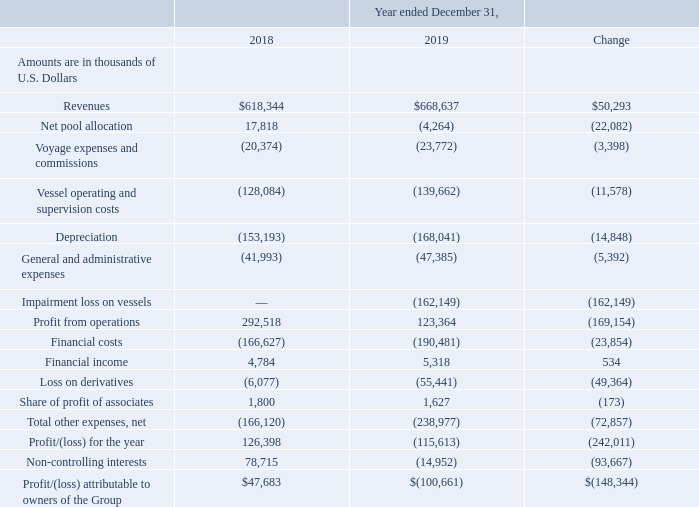Results of Operations
Year Ended December 31, 2018 Compared to Year Ended December 31, 2019
During the year ended December 31, 2019, we had an average of 27.2 ships operating in our owned and bareboat fleet (including ships owned by the Partnership), having 9,518 revenue operating days and an average of 27.2 ships operating under our technical management (including 27.0 of our owned and bareboat ships). During the year ended December 31, 2018, we had an average of 26.0 ships operating in our owned and bareboat fleet (including ships owned by the Partnership), having 9,030 revenue operating days and an average of 25.5 ships operating under our technical management (including 25.0 of our owned and bareboat ships).
Revenues: Revenues increased by 8.1%, or $50.3 million, from $618.3 million during the year ended December 31, 2018 to $668.6 million during the year ended December 31, 2019. The increase in revenues is mainly attributable to an increase of $63.4 million deriving from the full operation of the GasLog Houston, the GasLog Hong Kong and the GasLog Gladstone which were delivered on January 8, 2018, March 20, 2018 and March 29, 2018, respectively and the deliveries of the GasLog Gladstone on March 15, 2019 and the GasLog Warsaw on July 31, 2019. These deliveries resulted in an increase in revenue operating days. In addition, there was an increase of $11.0 million from our vessels trading in the spot and short-term market including the impact of the unscheduled dry-dockings of the GasLog Savannah, the GasLog Singapore and the GasLog Chelsea and an increase of $2.7 million from the remaining fleet. The above increases were partially offset by a decrease of $26.1 million from the expiration of the initial time charters of the GasLog Shanghai, the GasLog Santiago, the GasLog Sydney, the GasLog Skagen, the GasLog Saratoga and the Methane Jane Elizabeth and a decrease of $0.7 million due to increased off-hire days from the remaining vessels. The average daily hire rate increased from $68,392 for the year ended December 31, 2018 to $70,167 for the year ended December 31, 2019.
How many ships on average are operating in 2019 and 2018 respectively? 27.2 ships, 26.0 ships. What was the change in revenue from 2018 to 2019? $50.3 million. What was the total revenue operating days in 2019? 9,518. Which year has a higher revenue? $668,637 >$618,344
Answer: 2019. What was the percentage change in profit from operations from 2018 to 2019?
Answer scale should be: percent. (123,364 - 292,518)/292,518 
Answer: -57.83. What was the change in average daily hire rate from 2018 to 2019? $70,167 - $68,392 
Answer: 1775. 